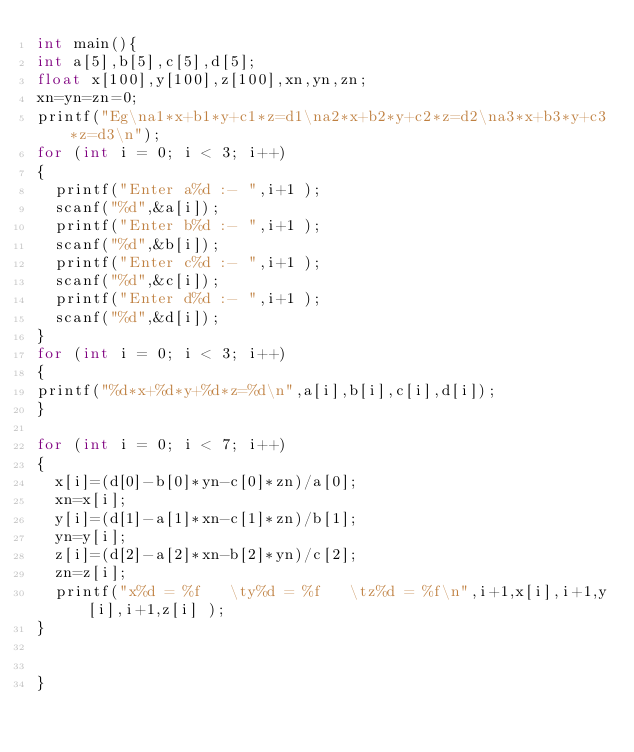<code> <loc_0><loc_0><loc_500><loc_500><_C_>int main(){
int a[5],b[5],c[5],d[5];
float x[100],y[100],z[100],xn,yn,zn;
xn=yn=zn=0;
printf("Eg\na1*x+b1*y+c1*z=d1\na2*x+b2*y+c2*z=d2\na3*x+b3*y+c3*z=d3\n");
for (int i = 0; i < 3; i++)
{
	printf("Enter a%d :- ",i+1 );
	scanf("%d",&a[i]);
	printf("Enter b%d :- ",i+1 );
	scanf("%d",&b[i]);
	printf("Enter c%d :- ",i+1 );
	scanf("%d",&c[i]);
	printf("Enter d%d :- ",i+1 );
	scanf("%d",&d[i]);
}
for (int i = 0; i < 3; i++)
{
printf("%d*x+%d*y+%d*z=%d\n",a[i],b[i],c[i],d[i]);
}

for (int i = 0; i < 7; i++)
{
	x[i]=(d[0]-b[0]*yn-c[0]*zn)/a[0];
	xn=x[i];
	y[i]=(d[1]-a[1]*xn-c[1]*zn)/b[1];
	yn=y[i];
	z[i]=(d[2]-a[2]*xn-b[2]*yn)/c[2];
	zn=z[i];
	printf("x%d = %f   \ty%d = %f   \tz%d = %f\n",i+1,x[i],i+1,y[i],i+1,z[i] );
}


}</code> 